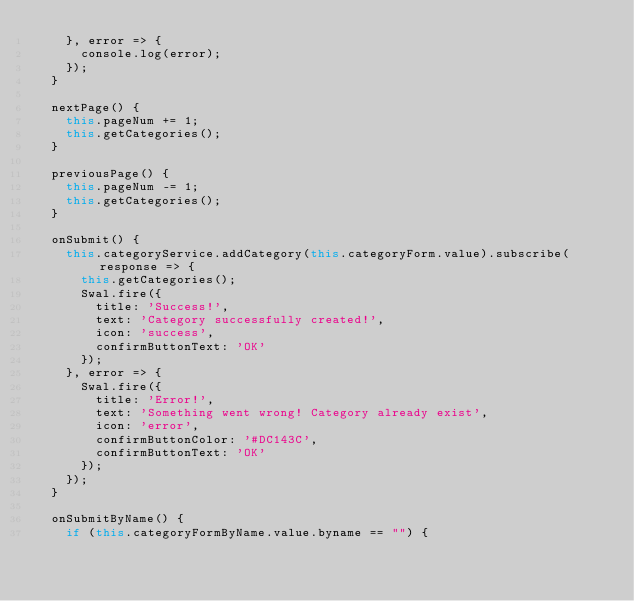Convert code to text. <code><loc_0><loc_0><loc_500><loc_500><_TypeScript_>    }, error => {
      console.log(error);
    });
  }

  nextPage() {
    this.pageNum += 1;
    this.getCategories();
  }

  previousPage() {
    this.pageNum -= 1;
    this.getCategories();
  }

  onSubmit() {
    this.categoryService.addCategory(this.categoryForm.value).subscribe(response => {
      this.getCategories();
      Swal.fire({
        title: 'Success!',
        text: 'Category successfully created!',
        icon: 'success',
        confirmButtonText: 'OK'
      });
    }, error => {
      Swal.fire({
        title: 'Error!',
        text: 'Something went wrong! Category already exist',
        icon: 'error',
        confirmButtonColor: '#DC143C',
        confirmButtonText: 'OK'
      });
    });
  }

  onSubmitByName() {
    if (this.categoryFormByName.value.byname == "") {</code> 